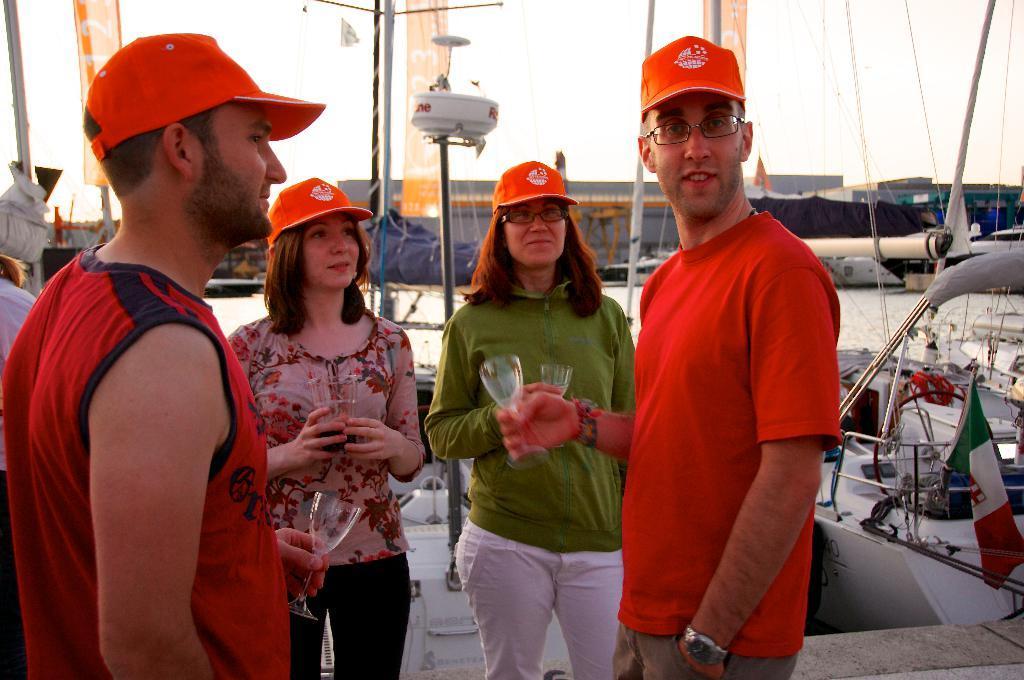How would you summarize this image in a sentence or two? In this image we can see a few people wearing same color cap and holding the glass, on the right side, we can see a vehicle, in the vehicle there is a flag, on the background we can see some poles. 